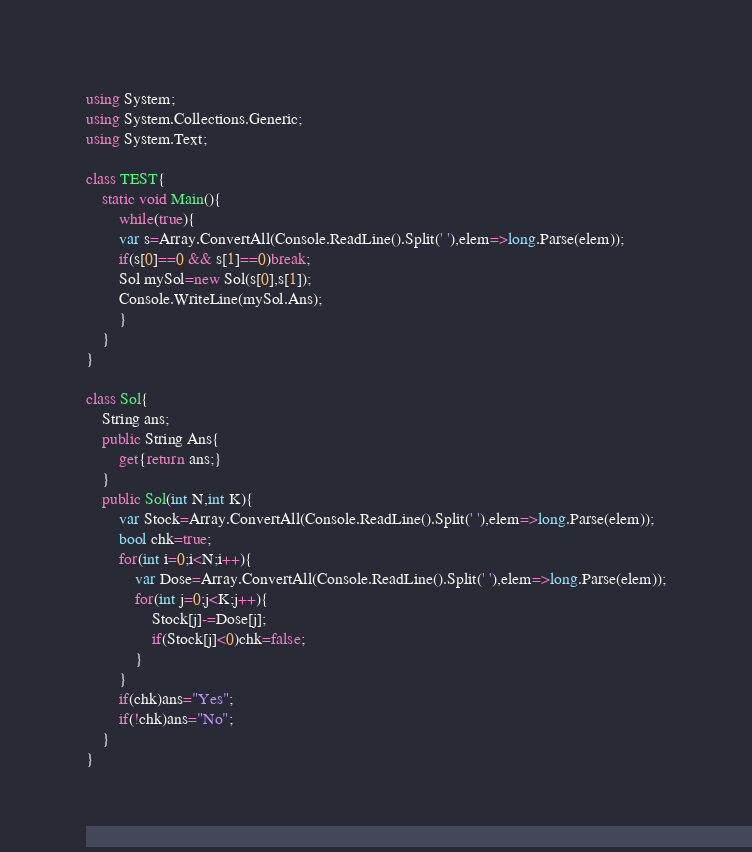<code> <loc_0><loc_0><loc_500><loc_500><_C#_>using System;
using System.Collections.Generic;
using System.Text;

class TEST{
	static void Main(){
		while(true){
		var s=Array.ConvertAll(Console.ReadLine().Split(' '),elem=>long.Parse(elem));
		if(s[0]==0 && s[1]==0)break;
		Sol mySol=new Sol(s[0],s[1]);
		Console.WriteLine(mySol.Ans);
		}
	}
}

class Sol{
	String ans;
	public String Ans{
		get{return ans;}
	}
	public Sol(int N,int K){
		var Stock=Array.ConvertAll(Console.ReadLine().Split(' '),elem=>long.Parse(elem));
		bool chk=true;
		for(int i=0;i<N;i++){
			var Dose=Array.ConvertAll(Console.ReadLine().Split(' '),elem=>long.Parse(elem));
			for(int j=0;j<K;j++){
				Stock[j]-=Dose[j];
				if(Stock[j]<0)chk=false;
			}
		}
		if(chk)ans="Yes";
		if(!chk)ans="No";
	}
}</code> 